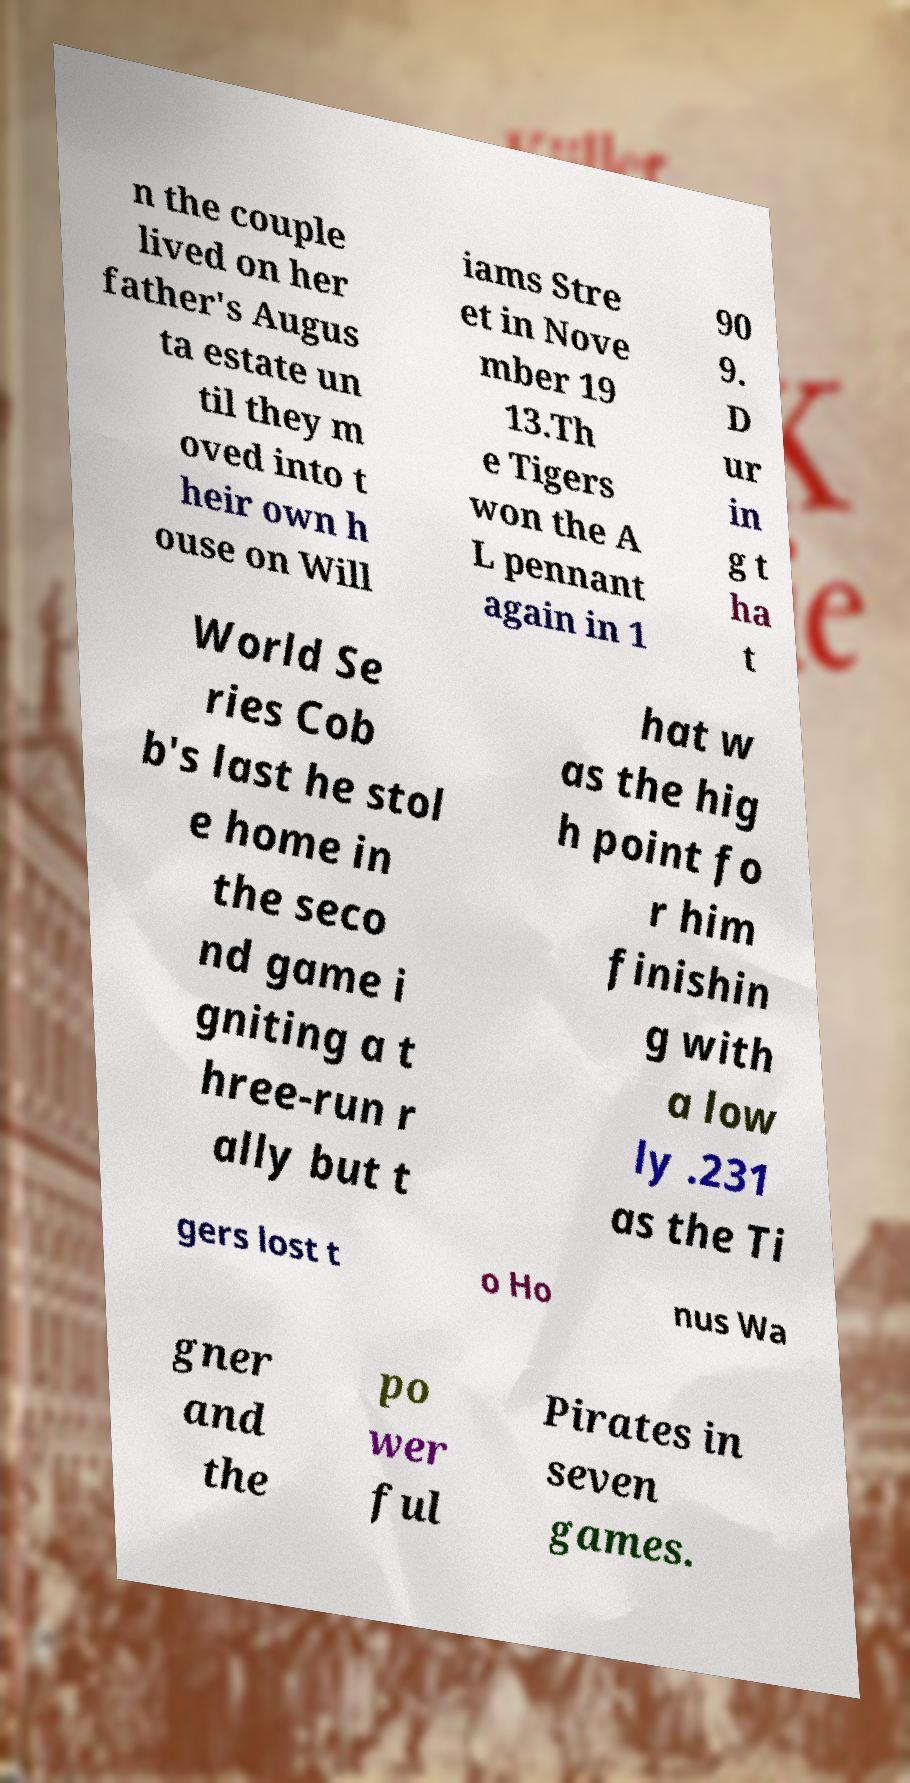There's text embedded in this image that I need extracted. Can you transcribe it verbatim? n the couple lived on her father's Augus ta estate un til they m oved into t heir own h ouse on Will iams Stre et in Nove mber 19 13.Th e Tigers won the A L pennant again in 1 90 9. D ur in g t ha t World Se ries Cob b's last he stol e home in the seco nd game i gniting a t hree-run r ally but t hat w as the hig h point fo r him finishin g with a low ly .231 as the Ti gers lost t o Ho nus Wa gner and the po wer ful Pirates in seven games. 